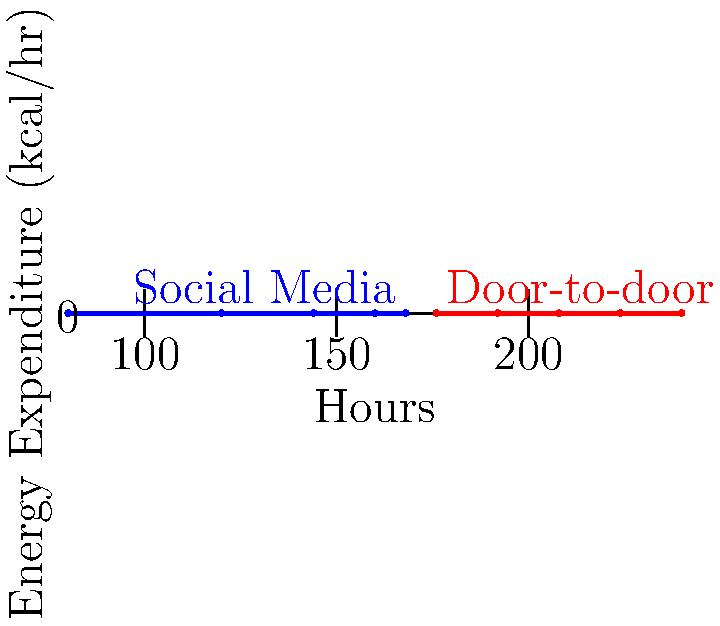Based on the graph showing energy expenditure for door-to-door canvassing versus social media campaigning, which method would be more effective for our party to maintain its stronghold and prevent the independent candidate from gaining ground? Justify your answer using the data provided. To answer this question, we need to analyze the graph and consider the implications for our party's strategy:

1. Energy expenditure comparison:
   - Door-to-door canvassing: Starts at about 300 kcal/hr and decreases to about 220 kcal/hr
   - Social media campaigning: Starts at about 100 kcal/hr and increases to about 210 kcal/hr

2. Effectiveness analysis:
   a. Door-to-door canvassing:
      - Higher initial energy expenditure indicates more intense personal interaction
      - Decreasing trend suggests fatigue over time, but still maintains higher energy output
      - Allows for direct voter contact and personalized messaging
      - Better for reinforcing party loyalty and addressing concerns immediately

   b. Social media campaigning:
      - Lower initial energy expenditure, but increases over time
      - Allows for broader reach and targeting specific demographics
      - Less personal interaction, which may be less effective in maintaining party loyalty

3. Strategy considerations:
   - Our goal is to maintain the party's stronghold and prevent the independent candidate from gaining ground
   - Personal interactions are crucial for reinforcing party loyalty and countering independent candidate's appeal
   - Door-to-door canvassing allows for immediate feedback and addressing voter concerns

4. Conclusion:
   Despite the higher energy expenditure, door-to-door canvassing would be more effective for our party to maintain its stronghold. The personal touch and direct interaction with voters will help reinforce party loyalty and counter any appeal the independent candidate may have. The higher energy expenditure indicates more intense engagement, which is crucial for maintaining our party's power base.
Answer: Door-to-door canvassing 